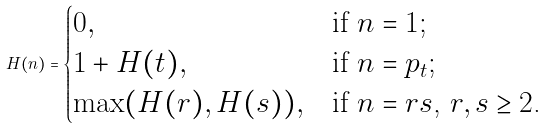Convert formula to latex. <formula><loc_0><loc_0><loc_500><loc_500>H ( n ) = \begin{cases} 0 , & \text {if $n=1$;} \\ 1 + H ( t ) , & \text {if $n=p_{t}$;} \\ \max ( H ( r ) , H ( s ) ) , & \text {if $n=rs$, $r,s \geq 2$.} \end{cases}</formula> 